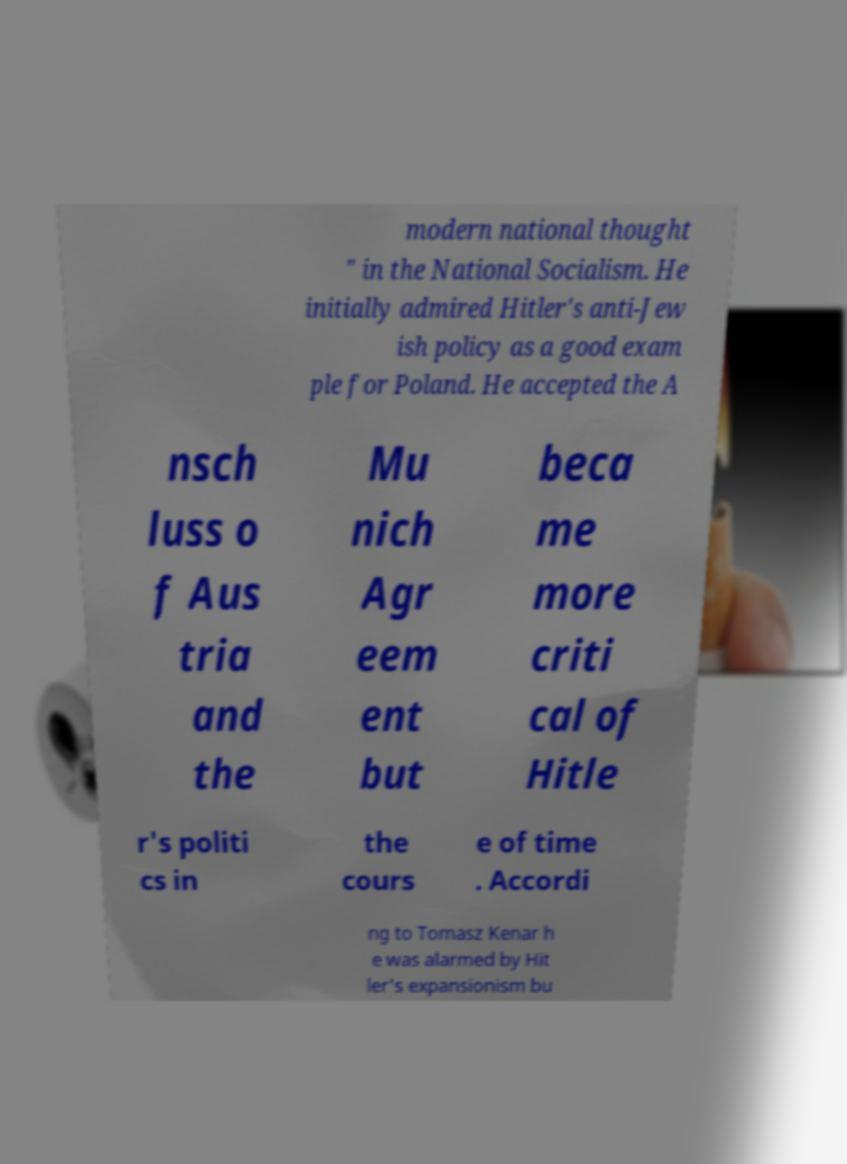Please read and relay the text visible in this image. What does it say? modern national thought " in the National Socialism. He initially admired Hitler's anti-Jew ish policy as a good exam ple for Poland. He accepted the A nsch luss o f Aus tria and the Mu nich Agr eem ent but beca me more criti cal of Hitle r's politi cs in the cours e of time . Accordi ng to Tomasz Kenar h e was alarmed by Hit ler's expansionism bu 